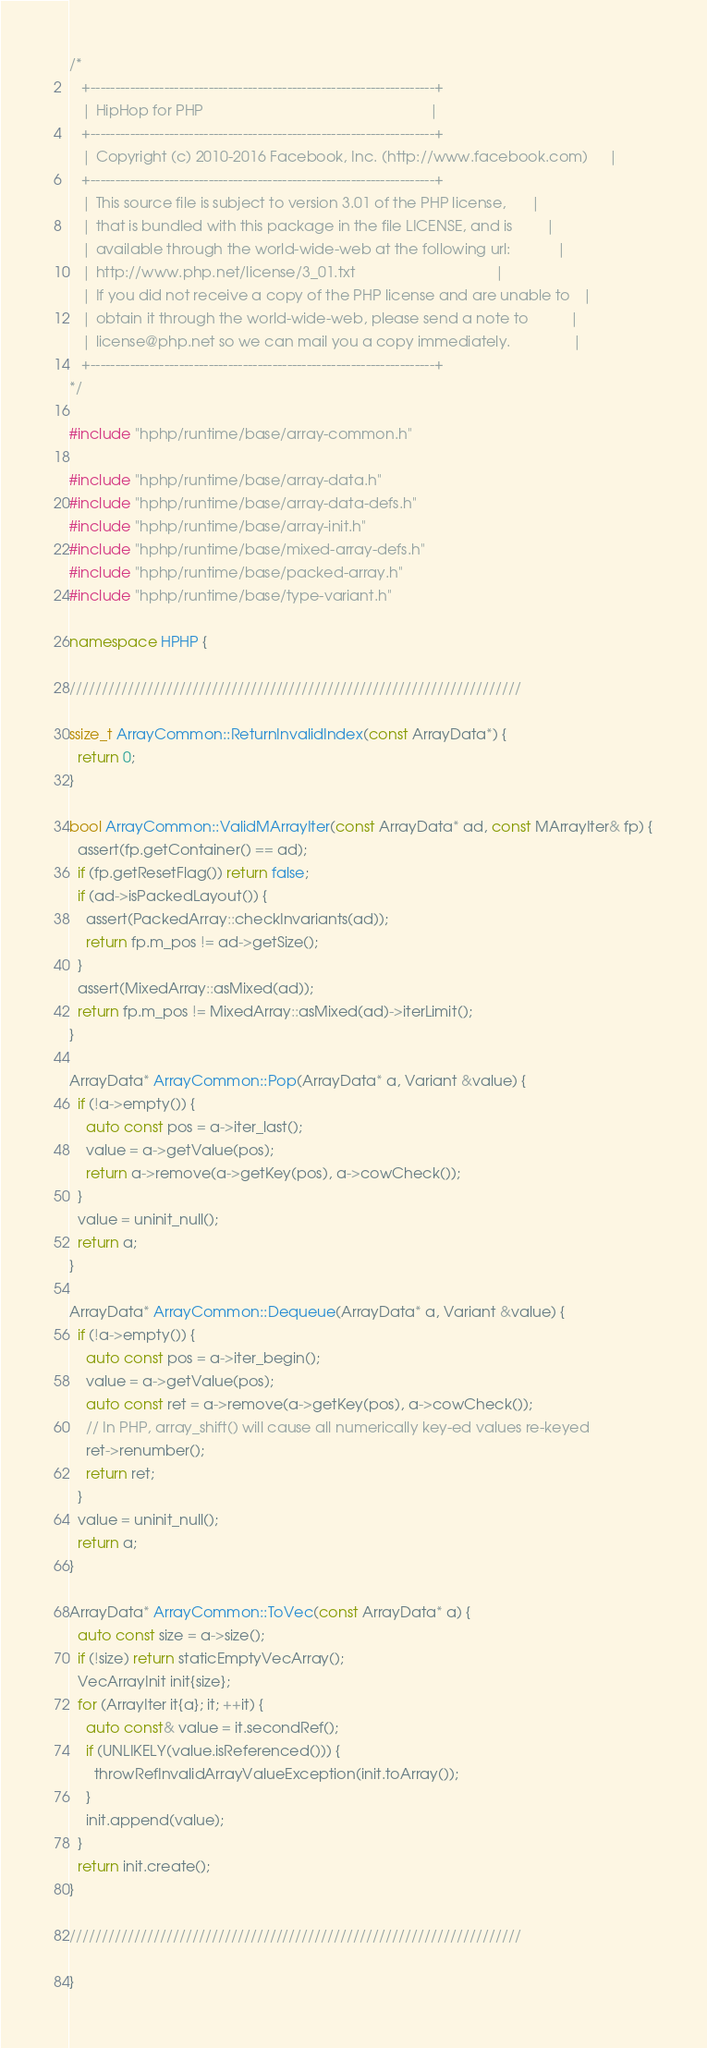Convert code to text. <code><loc_0><loc_0><loc_500><loc_500><_C++_>/*
   +----------------------------------------------------------------------+
   | HipHop for PHP                                                       |
   +----------------------------------------------------------------------+
   | Copyright (c) 2010-2016 Facebook, Inc. (http://www.facebook.com)     |
   +----------------------------------------------------------------------+
   | This source file is subject to version 3.01 of the PHP license,      |
   | that is bundled with this package in the file LICENSE, and is        |
   | available through the world-wide-web at the following url:           |
   | http://www.php.net/license/3_01.txt                                  |
   | If you did not receive a copy of the PHP license and are unable to   |
   | obtain it through the world-wide-web, please send a note to          |
   | license@php.net so we can mail you a copy immediately.               |
   +----------------------------------------------------------------------+
*/

#include "hphp/runtime/base/array-common.h"

#include "hphp/runtime/base/array-data.h"
#include "hphp/runtime/base/array-data-defs.h"
#include "hphp/runtime/base/array-init.h"
#include "hphp/runtime/base/mixed-array-defs.h"
#include "hphp/runtime/base/packed-array.h"
#include "hphp/runtime/base/type-variant.h"

namespace HPHP {

//////////////////////////////////////////////////////////////////////

ssize_t ArrayCommon::ReturnInvalidIndex(const ArrayData*) {
  return 0;
}

bool ArrayCommon::ValidMArrayIter(const ArrayData* ad, const MArrayIter& fp) {
  assert(fp.getContainer() == ad);
  if (fp.getResetFlag()) return false;
  if (ad->isPackedLayout()) {
    assert(PackedArray::checkInvariants(ad));
    return fp.m_pos != ad->getSize();
  }
  assert(MixedArray::asMixed(ad));
  return fp.m_pos != MixedArray::asMixed(ad)->iterLimit();
}

ArrayData* ArrayCommon::Pop(ArrayData* a, Variant &value) {
  if (!a->empty()) {
    auto const pos = a->iter_last();
    value = a->getValue(pos);
    return a->remove(a->getKey(pos), a->cowCheck());
  }
  value = uninit_null();
  return a;
}

ArrayData* ArrayCommon::Dequeue(ArrayData* a, Variant &value) {
  if (!a->empty()) {
    auto const pos = a->iter_begin();
    value = a->getValue(pos);
    auto const ret = a->remove(a->getKey(pos), a->cowCheck());
    // In PHP, array_shift() will cause all numerically key-ed values re-keyed
    ret->renumber();
    return ret;
  }
  value = uninit_null();
  return a;
}

ArrayData* ArrayCommon::ToVec(const ArrayData* a) {
  auto const size = a->size();
  if (!size) return staticEmptyVecArray();
  VecArrayInit init{size};
  for (ArrayIter it{a}; it; ++it) {
    auto const& value = it.secondRef();
    if (UNLIKELY(value.isReferenced())) {
      throwRefInvalidArrayValueException(init.toArray());
    }
    init.append(value);
  }
  return init.create();
}

//////////////////////////////////////////////////////////////////////

}
</code> 